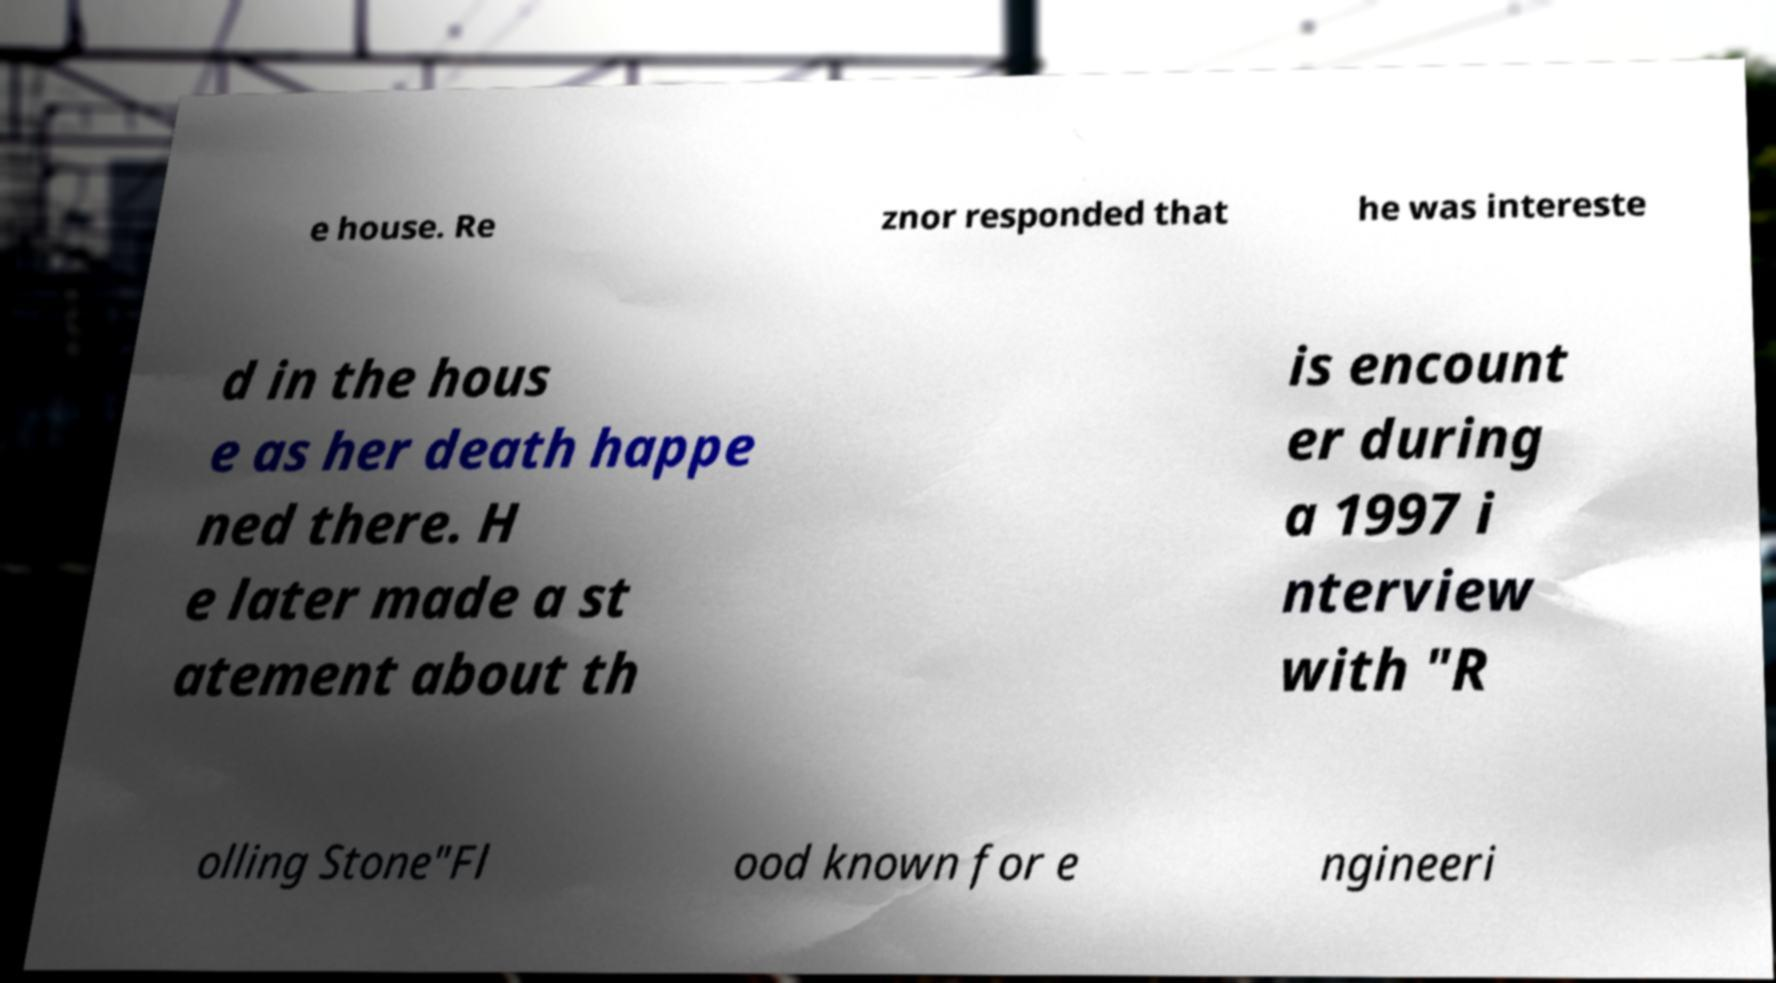Could you extract and type out the text from this image? e house. Re znor responded that he was intereste d in the hous e as her death happe ned there. H e later made a st atement about th is encount er during a 1997 i nterview with "R olling Stone"Fl ood known for e ngineeri 